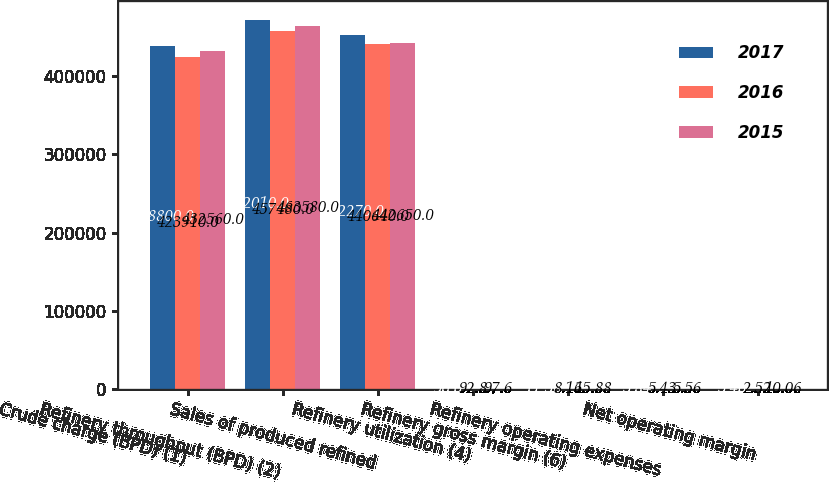Convert chart. <chart><loc_0><loc_0><loc_500><loc_500><stacked_bar_chart><ecel><fcel>Crude charge (BPD) (1)<fcel>Refinery throughput (BPD) (2)<fcel>Sales of produced refined<fcel>Refinery utilization (4)<fcel>Refinery gross margin (6)<fcel>Refinery operating expenses<fcel>Net operating margin<nl><fcel>2017<fcel>438800<fcel>472010<fcel>452270<fcel>96<fcel>11.56<fcel>5.84<fcel>5.46<nl><fcel>2016<fcel>423910<fcel>457480<fcel>440640<fcel>92.8<fcel>8.16<fcel>5.43<fcel>2.52<nl><fcel>2015<fcel>432560<fcel>463580<fcel>442650<fcel>97.6<fcel>15.88<fcel>5.56<fcel>10.06<nl></chart> 